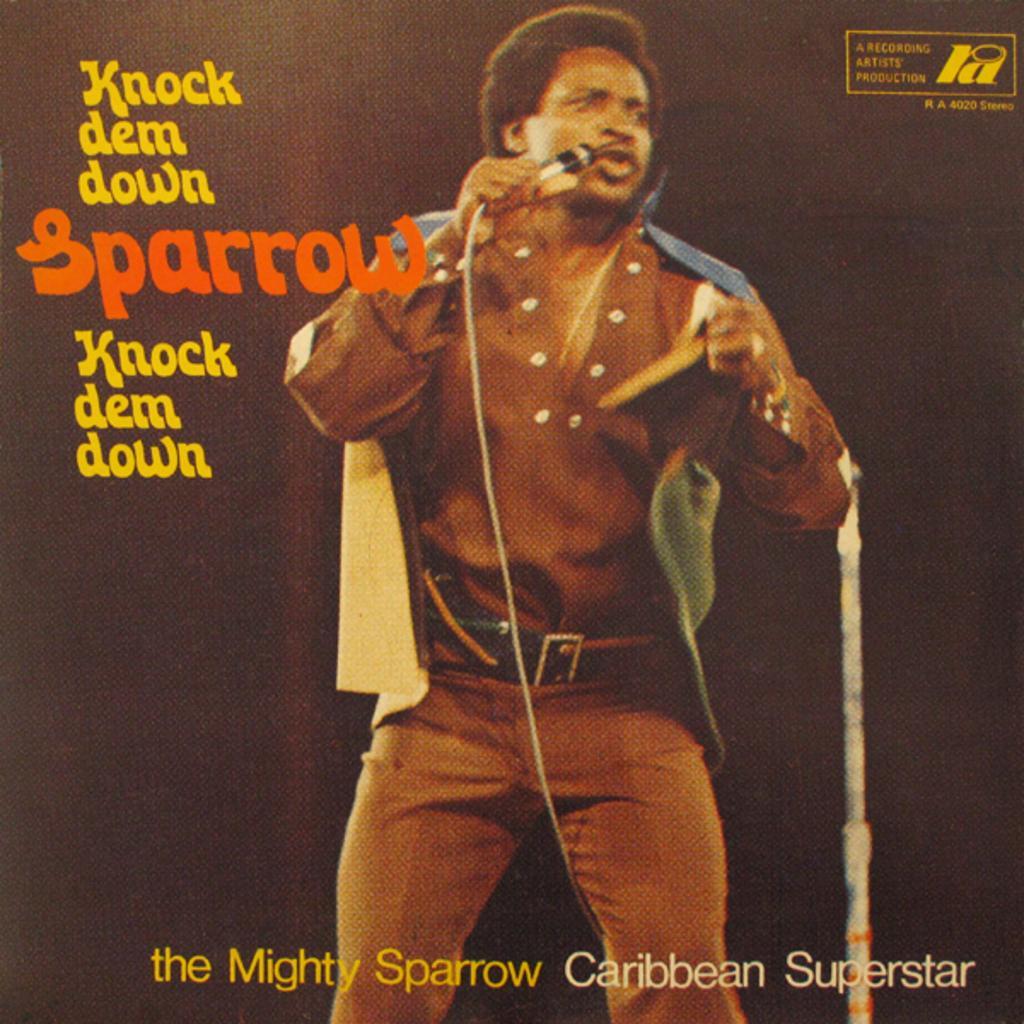Could you give a brief overview of what you see in this image? In this image we can see a poster on which we can see a person wearing costume is holding a mic and standing. Here we can see some edited text and watermark at the top right side of the image. 